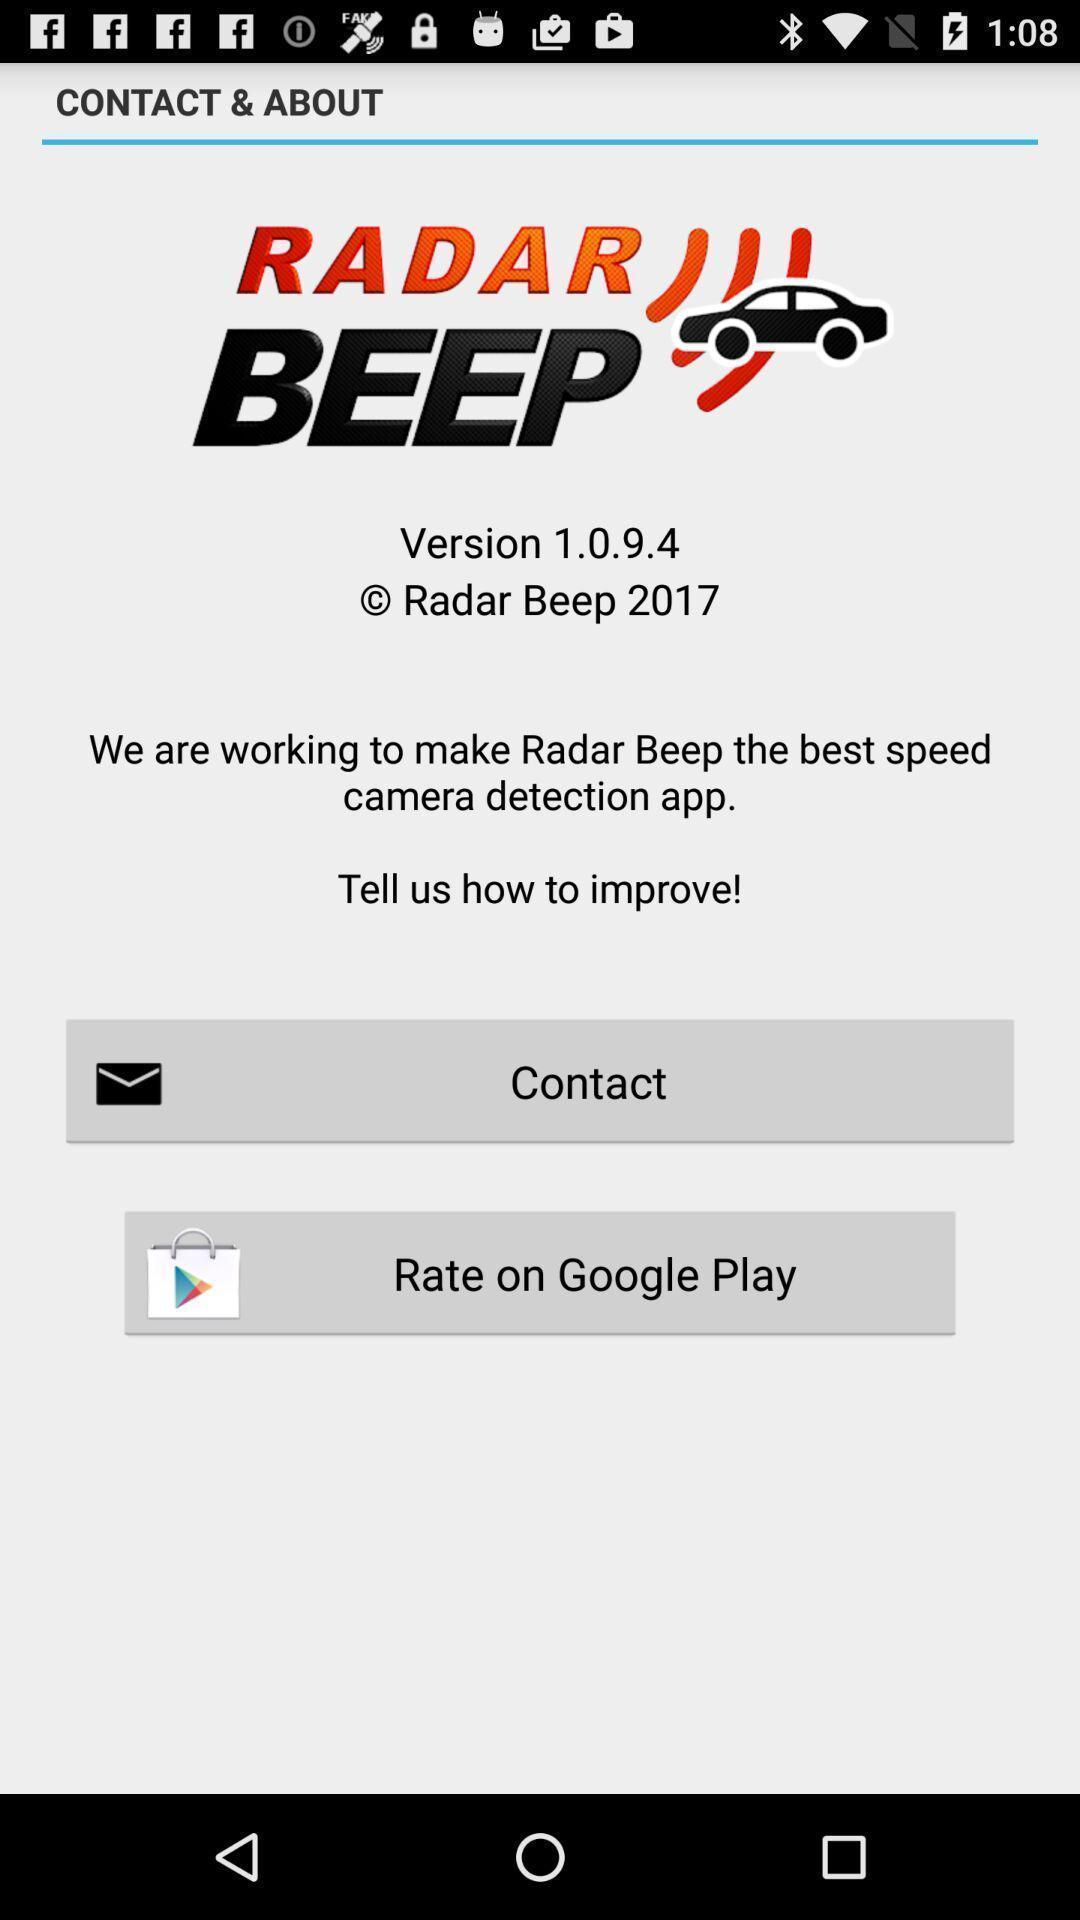Tell me about the visual elements in this screen capture. Screen displaying contact and about page. 